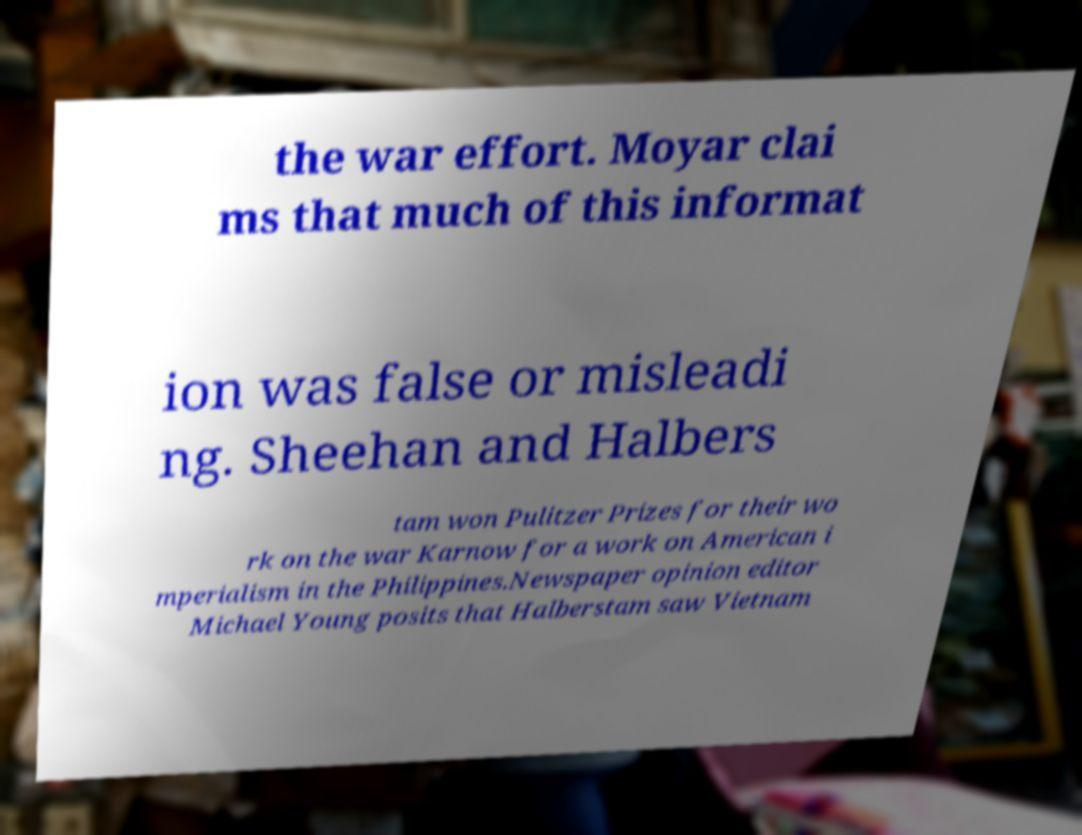There's text embedded in this image that I need extracted. Can you transcribe it verbatim? the war effort. Moyar clai ms that much of this informat ion was false or misleadi ng. Sheehan and Halbers tam won Pulitzer Prizes for their wo rk on the war Karnow for a work on American i mperialism in the Philippines.Newspaper opinion editor Michael Young posits that Halberstam saw Vietnam 